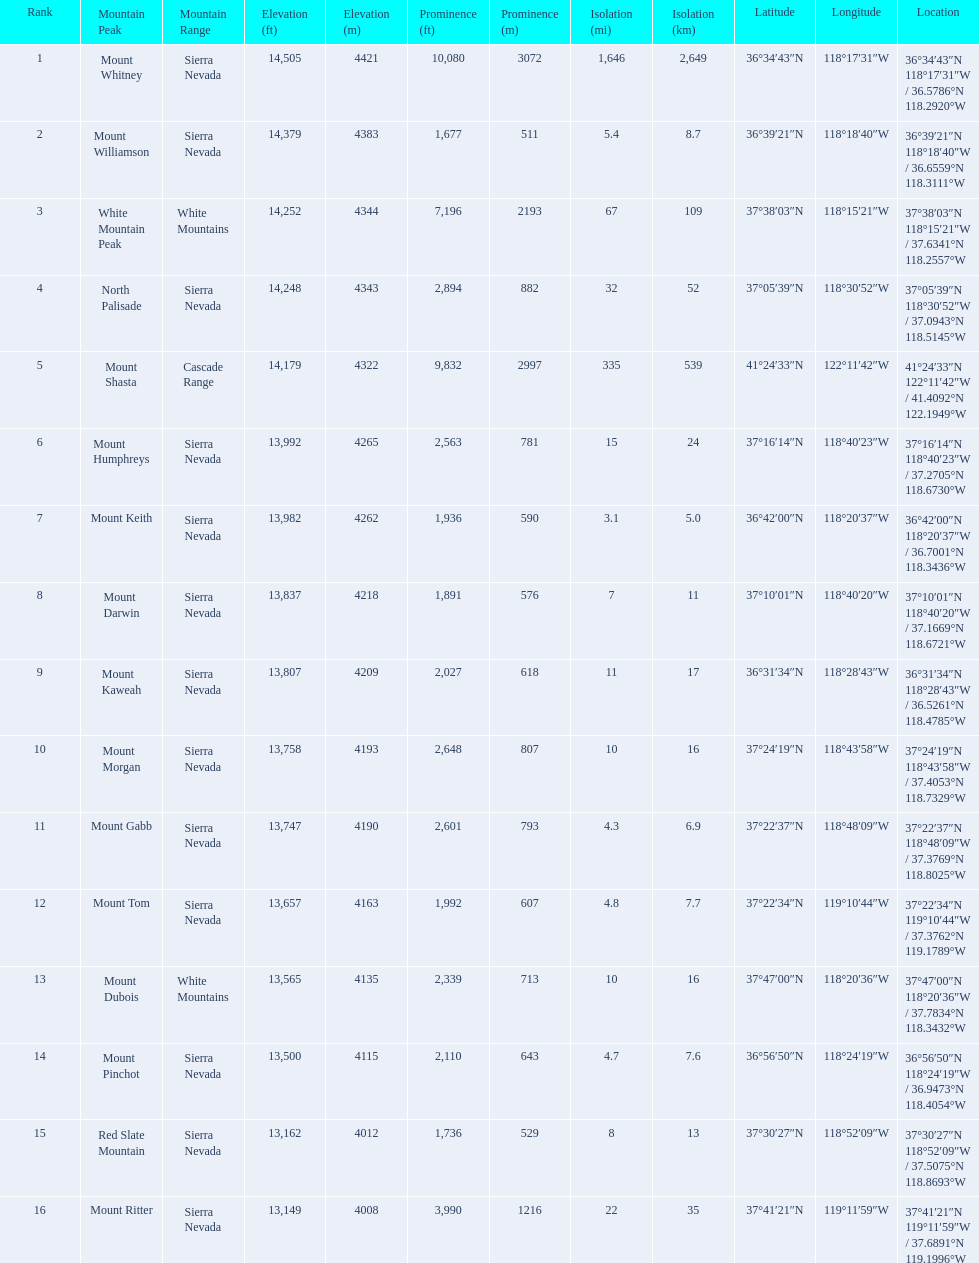What are the heights of the californian mountain peaks? 14,505 ft\n4421 m, 14,379 ft\n4383 m, 14,252 ft\n4344 m, 14,248 ft\n4343 m, 14,179 ft\n4322 m, 13,992 ft\n4265 m, 13,982 ft\n4262 m, 13,837 ft\n4218 m, 13,807 ft\n4209 m, 13,758 ft\n4193 m, 13,747 ft\n4190 m, 13,657 ft\n4163 m, 13,565 ft\n4135 m, 13,500 ft\n4115 m, 13,162 ft\n4012 m, 13,149 ft\n4008 m. What elevation is 13,149 ft or less? 13,149 ft\n4008 m. What mountain peak is at this elevation? Mount Ritter. Give me the full table as a dictionary. {'header': ['Rank', 'Mountain Peak', 'Mountain Range', 'Elevation (ft)', 'Elevation (m)', 'Prominence (ft)', 'Prominence (m)', 'Isolation (mi)', 'Isolation (km)', 'Latitude', 'Longitude', 'Location'], 'rows': [['1', 'Mount Whitney', 'Sierra Nevada', '14,505', '4421', '10,080', '3072', '1,646', '2,649', '36°34′43″N', '118°17′31″W\ufeff', '36°34′43″N 118°17′31″W\ufeff / \ufeff36.5786°N 118.2920°W'], ['2', 'Mount Williamson', 'Sierra Nevada', '14,379', '4383', '1,677', '511', '5.4', '8.7', '36°39′21″N', '118°18′40″W\ufeff', '36°39′21″N 118°18′40″W\ufeff / \ufeff36.6559°N 118.3111°W'], ['3', 'White Mountain Peak', 'White Mountains', '14,252', '4344', '7,196', '2193', '67', '109', '37°38′03″N', '118°15′21″W\ufeff', '37°38′03″N 118°15′21″W\ufeff / \ufeff37.6341°N 118.2557°W'], ['4', 'North Palisade', 'Sierra Nevada', '14,248', '4343', '2,894', '882', '32', '52', '37°05′39″N', '118°30′52″W\ufeff', '37°05′39″N 118°30′52″W\ufeff / \ufeff37.0943°N 118.5145°W'], ['5', 'Mount Shasta', 'Cascade Range', '14,179', '4322', '9,832', '2997', '335', '539', '41°24′33″N', '122°11′42″W\ufeff', '41°24′33″N 122°11′42″W\ufeff / \ufeff41.4092°N 122.1949°W'], ['6', 'Mount Humphreys', 'Sierra Nevada', '13,992', '4265', '2,563', '781', '15', '24', '37°16′14″N', '118°40′23″W\ufeff', '37°16′14″N 118°40′23″W\ufeff / \ufeff37.2705°N 118.6730°W'], ['7', 'Mount Keith', 'Sierra Nevada', '13,982', '4262', '1,936', '590', '3.1', '5.0', '36°42′00″N', '118°20′37″W\ufeff', '36°42′00″N 118°20′37″W\ufeff / \ufeff36.7001°N 118.3436°W'], ['8', 'Mount Darwin', 'Sierra Nevada', '13,837', '4218', '1,891', '576', '7', '11', '37°10′01″N', '118°40′20″W\ufeff', '37°10′01″N 118°40′20″W\ufeff / \ufeff37.1669°N 118.6721°W'], ['9', 'Mount Kaweah', 'Sierra Nevada', '13,807', '4209', '2,027', '618', '11', '17', '36°31′34″N', '118°28′43″W\ufeff', '36°31′34″N 118°28′43″W\ufeff / \ufeff36.5261°N 118.4785°W'], ['10', 'Mount Morgan', 'Sierra Nevada', '13,758', '4193', '2,648', '807', '10', '16', '37°24′19″N', '118°43′58″W\ufeff', '37°24′19″N 118°43′58″W\ufeff / \ufeff37.4053°N 118.7329°W'], ['11', 'Mount Gabb', 'Sierra Nevada', '13,747', '4190', '2,601', '793', '4.3', '6.9', '37°22′37″N', '118°48′09″W\ufeff', '37°22′37″N 118°48′09″W\ufeff / \ufeff37.3769°N 118.8025°W'], ['12', 'Mount Tom', 'Sierra Nevada', '13,657', '4163', '1,992', '607', '4.8', '7.7', '37°22′34″N', '119°10′44″W\ufeff', '37°22′34″N 119°10′44″W\ufeff / \ufeff37.3762°N 119.1789°W'], ['13', 'Mount Dubois', 'White Mountains', '13,565', '4135', '2,339', '713', '10', '16', '37°47′00″N', '118°20′36″W\ufeff', '37°47′00″N 118°20′36″W\ufeff / \ufeff37.7834°N 118.3432°W'], ['14', 'Mount Pinchot', 'Sierra Nevada', '13,500', '4115', '2,110', '643', '4.7', '7.6', '36°56′50″N', '118°24′19″W\ufeff', '36°56′50″N 118°24′19″W\ufeff / \ufeff36.9473°N 118.4054°W'], ['15', 'Red Slate Mountain', 'Sierra Nevada', '13,162', '4012', '1,736', '529', '8', '13', '37°30′27″N', '118°52′09″W\ufeff', '37°30′27″N 118°52′09″W\ufeff / \ufeff37.5075°N 118.8693°W'], ['16', 'Mount Ritter', 'Sierra Nevada', '13,149', '4008', '3,990', '1216', '22', '35', '37°41′21″N', '119°11′59″W\ufeff', '37°41′21″N 119°11′59″W\ufeff / \ufeff37.6891°N 119.1996°W']]} 